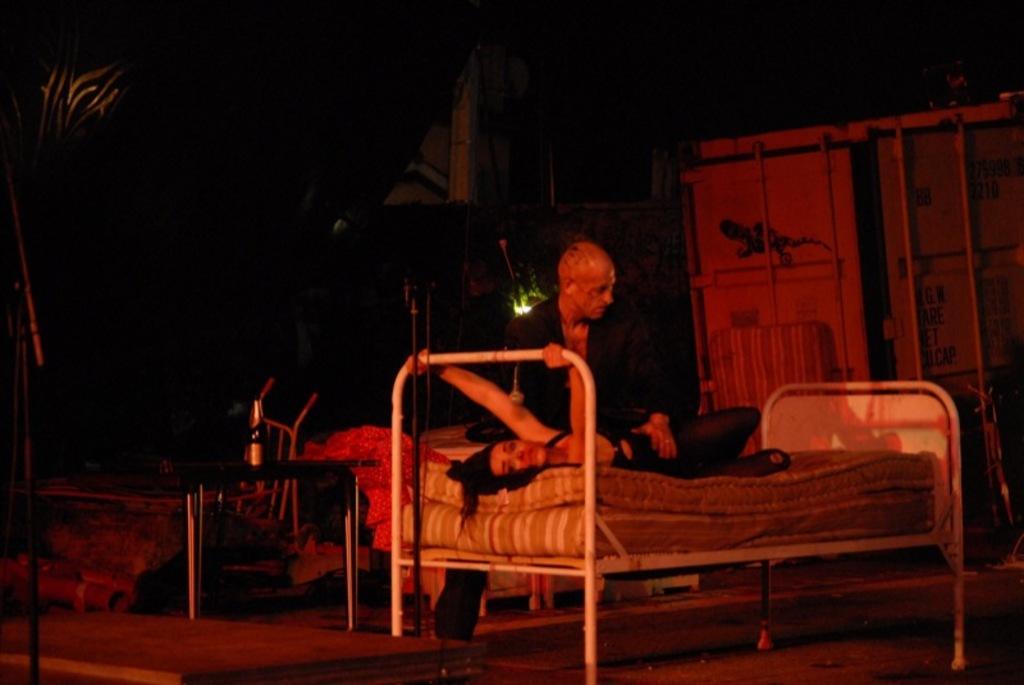How would you summarize this image in a sentence or two? In this picture we see a woman on the bed and we see a man holding her and we see a bottle on the table and a wooden cupboard on the back and a tree on the side and i can see a building on the back. 